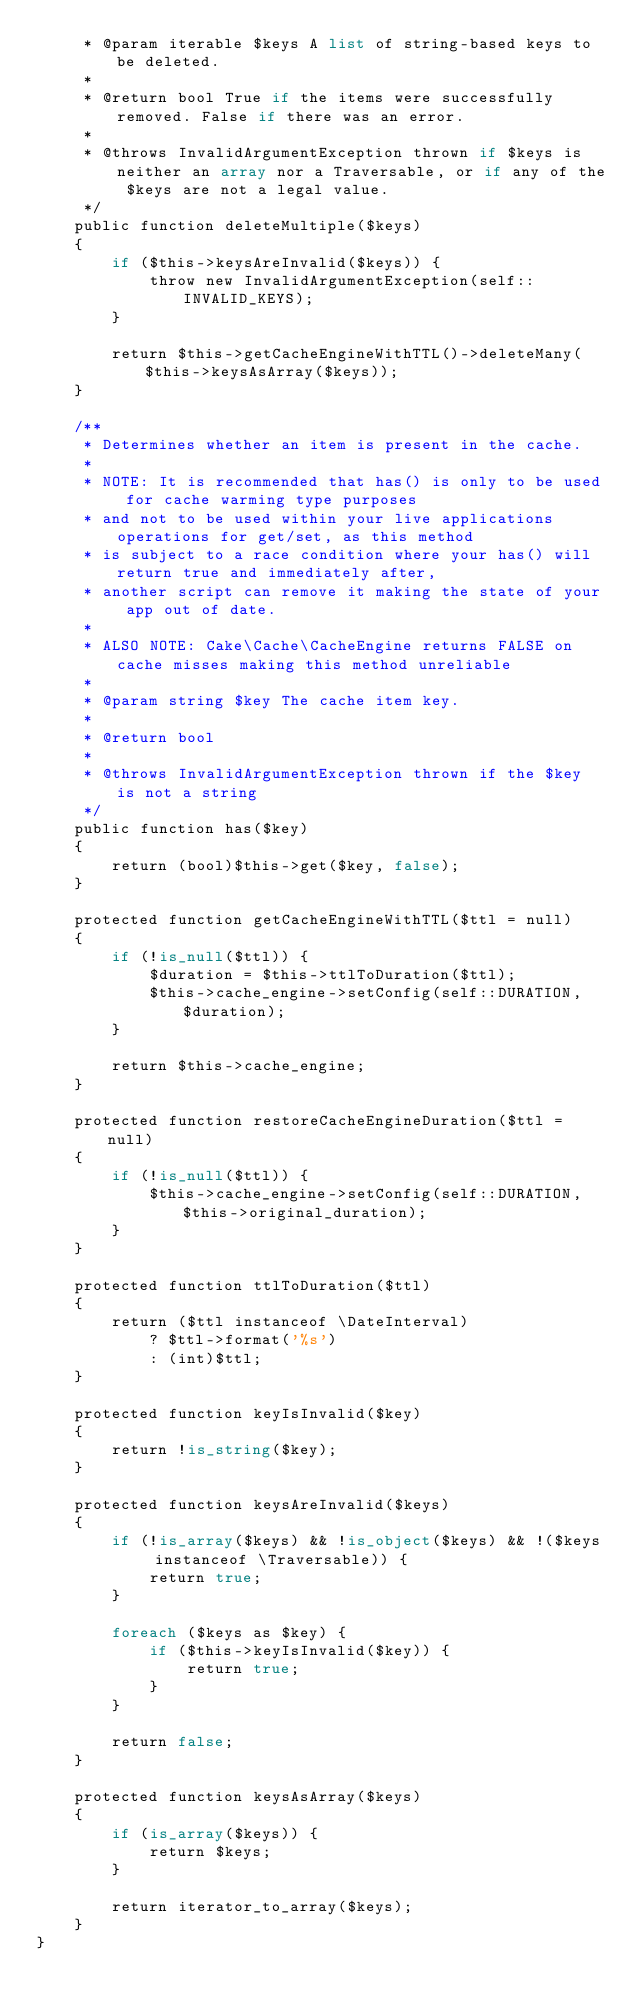Convert code to text. <code><loc_0><loc_0><loc_500><loc_500><_PHP_>     * @param iterable $keys A list of string-based keys to be deleted.
     *
     * @return bool True if the items were successfully removed. False if there was an error.
     *
     * @throws InvalidArgumentException thrown if $keys is neither an array nor a Traversable, or if any of the $keys are not a legal value.
     */
    public function deleteMultiple($keys)
    {
        if ($this->keysAreInvalid($keys)) {
            throw new InvalidArgumentException(self::INVALID_KEYS);
        }

        return $this->getCacheEngineWithTTL()->deleteMany($this->keysAsArray($keys));
    }

    /**
     * Determines whether an item is present in the cache.
     *
     * NOTE: It is recommended that has() is only to be used for cache warming type purposes
     * and not to be used within your live applications operations for get/set, as this method
     * is subject to a race condition where your has() will return true and immediately after,
     * another script can remove it making the state of your app out of date.
     *
     * ALSO NOTE: Cake\Cache\CacheEngine returns FALSE on cache misses making this method unreliable
     *
     * @param string $key The cache item key.
     *
     * @return bool
     *
     * @throws InvalidArgumentException thrown if the $key is not a string
     */
    public function has($key)
    {
        return (bool)$this->get($key, false);
    }

    protected function getCacheEngineWithTTL($ttl = null)
    {
        if (!is_null($ttl)) {
            $duration = $this->ttlToDuration($ttl);
            $this->cache_engine->setConfig(self::DURATION, $duration);
        }

        return $this->cache_engine;
    }

    protected function restoreCacheEngineDuration($ttl = null)
    {
        if (!is_null($ttl)) {
            $this->cache_engine->setConfig(self::DURATION, $this->original_duration);
        }
    }

    protected function ttlToDuration($ttl)
    {
        return ($ttl instanceof \DateInterval)
            ? $ttl->format('%s')
            : (int)$ttl;
    }

    protected function keyIsInvalid($key)
    {
        return !is_string($key);
    }

    protected function keysAreInvalid($keys)
    {
        if (!is_array($keys) && !is_object($keys) && !($keys instanceof \Traversable)) {
            return true;
        }

        foreach ($keys as $key) {
            if ($this->keyIsInvalid($key)) {
                return true;
            }
        }

        return false;
    }

    protected function keysAsArray($keys)
    {
        if (is_array($keys)) {
            return $keys;
        }

        return iterator_to_array($keys);
    }
}
</code> 